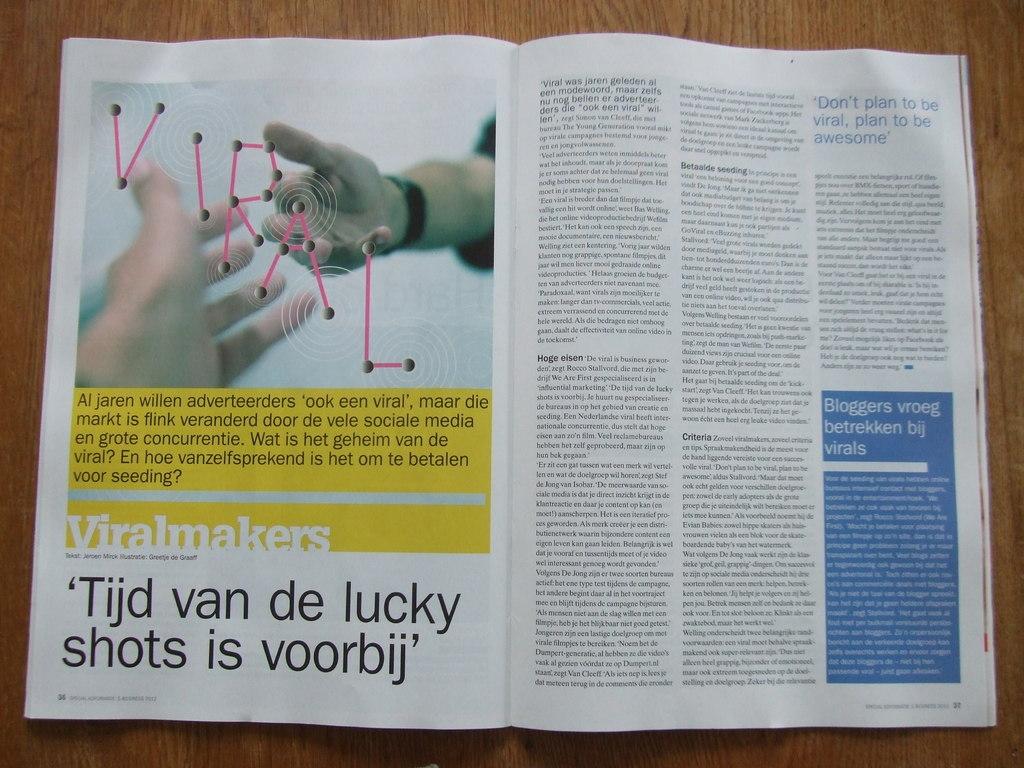What is the subject of the article?
Offer a very short reply. Viral. What does the magazine suggest you should plan to be instead of viral?
Offer a very short reply. Awesome. 